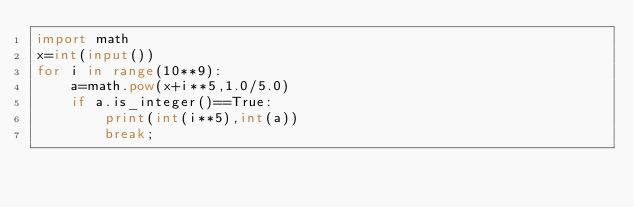<code> <loc_0><loc_0><loc_500><loc_500><_Python_>import math
x=int(input())
for i in range(10**9):
    a=math.pow(x+i**5,1.0/5.0)
    if a.is_integer()==True:
        print(int(i**5),int(a))
        break;</code> 